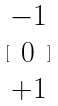Convert formula to latex. <formula><loc_0><loc_0><loc_500><loc_500>[ \begin{matrix} - 1 \\ 0 \\ + 1 \end{matrix} ]</formula> 